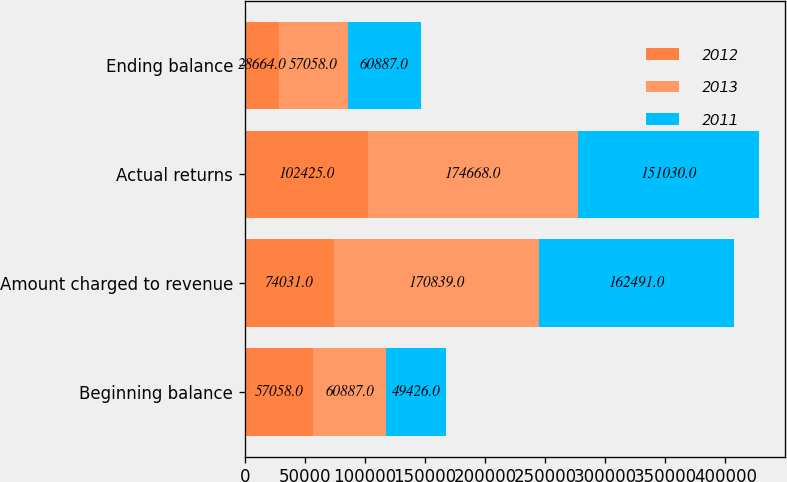Convert chart to OTSL. <chart><loc_0><loc_0><loc_500><loc_500><stacked_bar_chart><ecel><fcel>Beginning balance<fcel>Amount charged to revenue<fcel>Actual returns<fcel>Ending balance<nl><fcel>2012<fcel>57058<fcel>74031<fcel>102425<fcel>28664<nl><fcel>2013<fcel>60887<fcel>170839<fcel>174668<fcel>57058<nl><fcel>2011<fcel>49426<fcel>162491<fcel>151030<fcel>60887<nl></chart> 